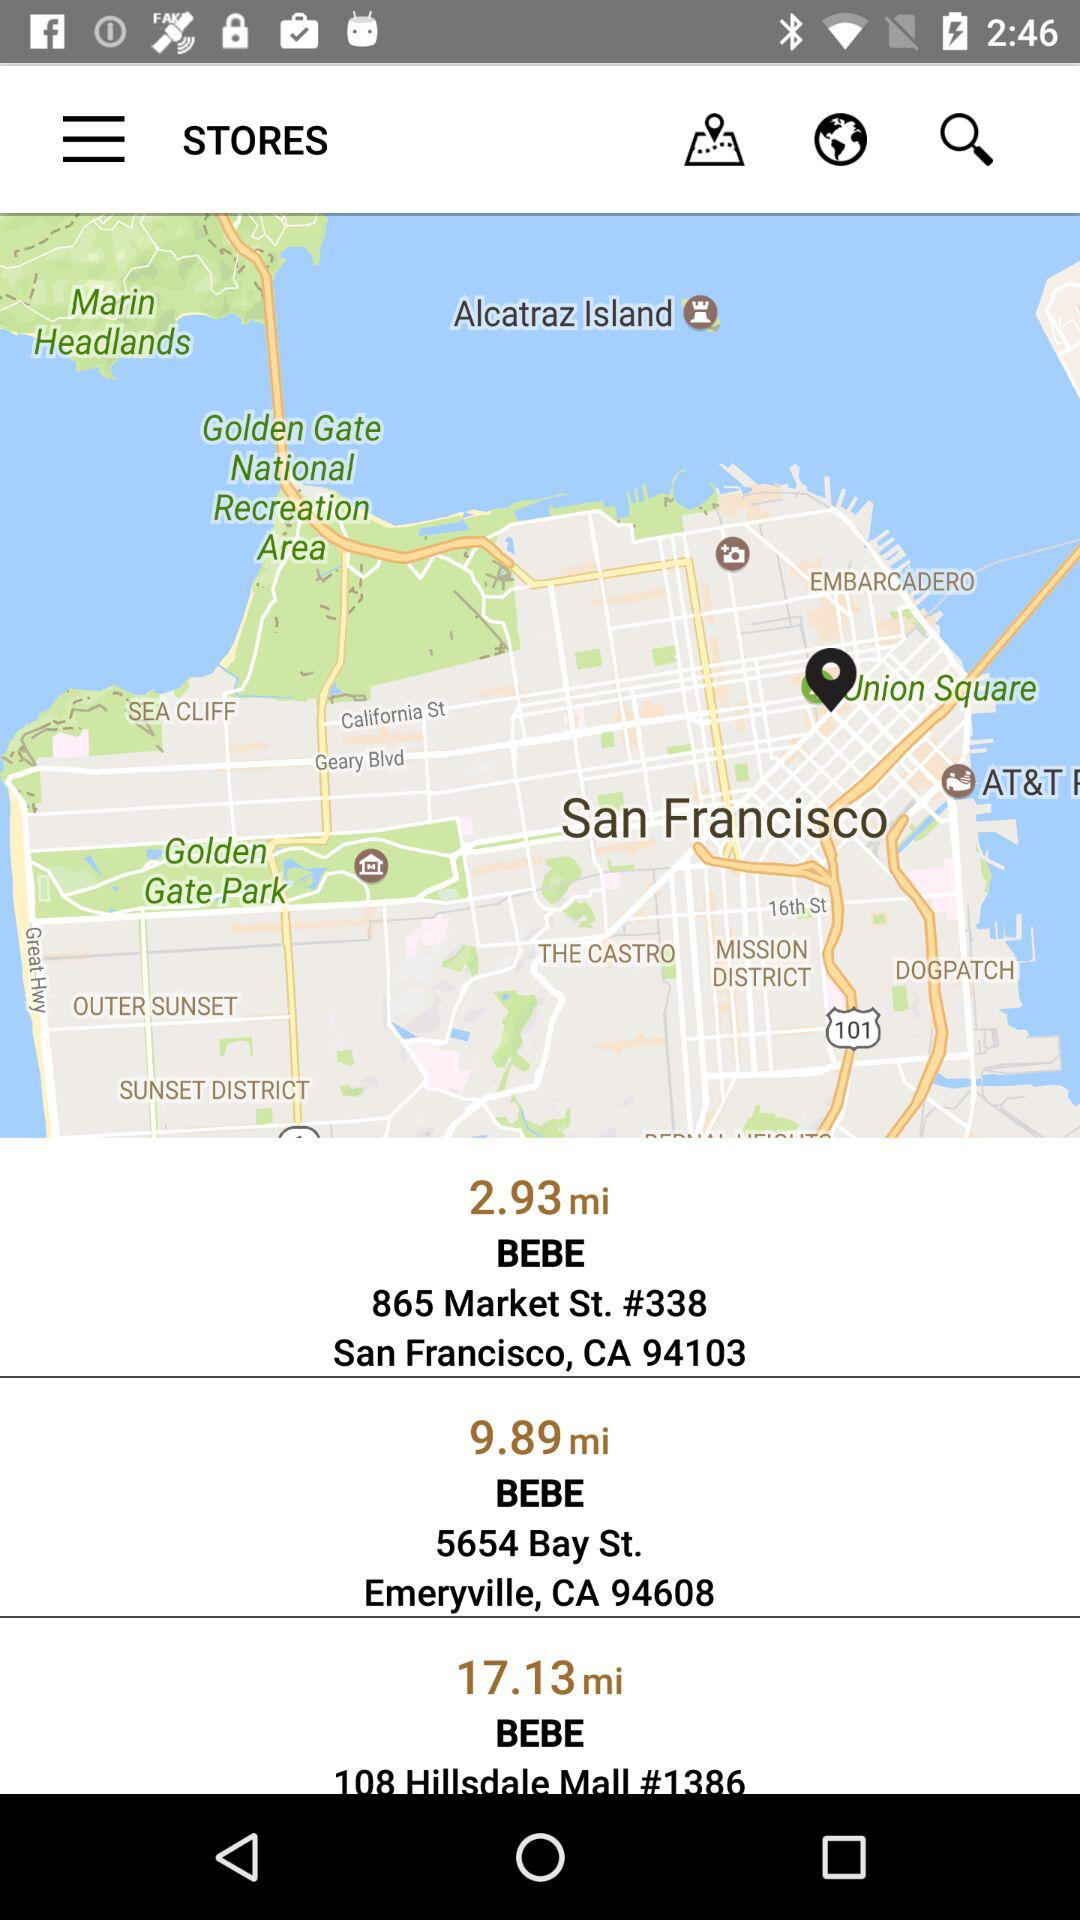How far is the Emeryville "BEBE" store? The Emeryville "BEBE" store is 9.89 miles away. 